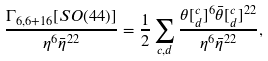<formula> <loc_0><loc_0><loc_500><loc_500>\frac { \Gamma _ { 6 , 6 + 1 6 } [ S O ( 4 4 ) ] } { \eta ^ { 6 } \bar { \eta } ^ { 2 2 } } = \frac { 1 } { 2 } \sum _ { c , d } \frac { \theta [ ^ { c } _ { d } ] ^ { 6 } \bar { \theta } [ ^ { c } _ { d } ] ^ { 2 2 } } { \eta ^ { 6 } \bar { \eta } ^ { 2 2 } } ,</formula> 